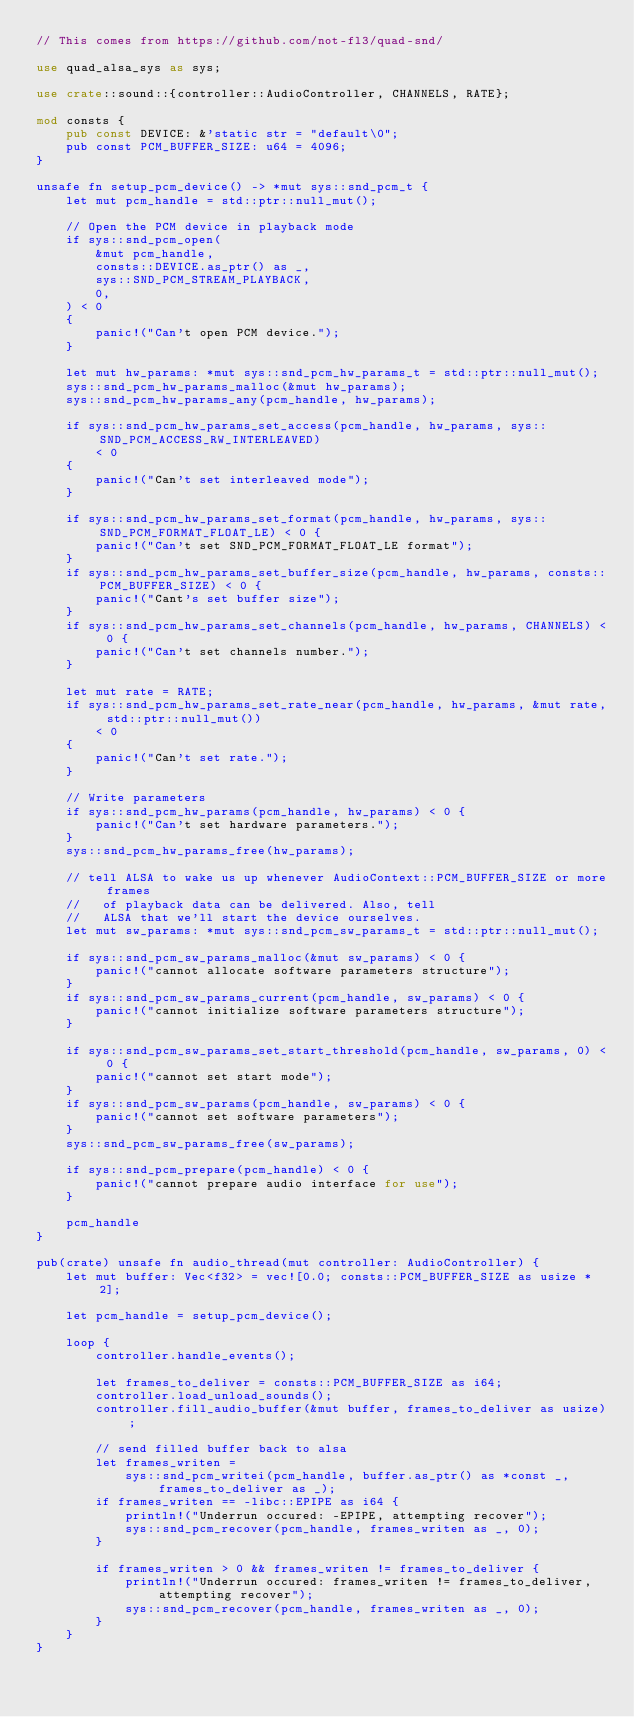<code> <loc_0><loc_0><loc_500><loc_500><_Rust_>// This comes from https://github.com/not-fl3/quad-snd/

use quad_alsa_sys as sys;

use crate::sound::{controller::AudioController, CHANNELS, RATE};

mod consts {
    pub const DEVICE: &'static str = "default\0";
    pub const PCM_BUFFER_SIZE: u64 = 4096;
}

unsafe fn setup_pcm_device() -> *mut sys::snd_pcm_t {
    let mut pcm_handle = std::ptr::null_mut();

    // Open the PCM device in playback mode
    if sys::snd_pcm_open(
        &mut pcm_handle,
        consts::DEVICE.as_ptr() as _,
        sys::SND_PCM_STREAM_PLAYBACK,
        0,
    ) < 0
    {
        panic!("Can't open PCM device.");
    }

    let mut hw_params: *mut sys::snd_pcm_hw_params_t = std::ptr::null_mut();
    sys::snd_pcm_hw_params_malloc(&mut hw_params);
    sys::snd_pcm_hw_params_any(pcm_handle, hw_params);

    if sys::snd_pcm_hw_params_set_access(pcm_handle, hw_params, sys::SND_PCM_ACCESS_RW_INTERLEAVED)
        < 0
    {
        panic!("Can't set interleaved mode");
    }

    if sys::snd_pcm_hw_params_set_format(pcm_handle, hw_params, sys::SND_PCM_FORMAT_FLOAT_LE) < 0 {
        panic!("Can't set SND_PCM_FORMAT_FLOAT_LE format");
    }
    if sys::snd_pcm_hw_params_set_buffer_size(pcm_handle, hw_params, consts::PCM_BUFFER_SIZE) < 0 {
        panic!("Cant's set buffer size");
    }
    if sys::snd_pcm_hw_params_set_channels(pcm_handle, hw_params, CHANNELS) < 0 {
        panic!("Can't set channels number.");
    }

    let mut rate = RATE;
    if sys::snd_pcm_hw_params_set_rate_near(pcm_handle, hw_params, &mut rate, std::ptr::null_mut())
        < 0
    {
        panic!("Can't set rate.");
    }

    // Write parameters
    if sys::snd_pcm_hw_params(pcm_handle, hw_params) < 0 {
        panic!("Can't set hardware parameters.");
    }
    sys::snd_pcm_hw_params_free(hw_params);

    // tell ALSA to wake us up whenever AudioContext::PCM_BUFFER_SIZE or more frames
    //   of playback data can be delivered. Also, tell
    //   ALSA that we'll start the device ourselves.
    let mut sw_params: *mut sys::snd_pcm_sw_params_t = std::ptr::null_mut();

    if sys::snd_pcm_sw_params_malloc(&mut sw_params) < 0 {
        panic!("cannot allocate software parameters structure");
    }
    if sys::snd_pcm_sw_params_current(pcm_handle, sw_params) < 0 {
        panic!("cannot initialize software parameters structure");
    }

    if sys::snd_pcm_sw_params_set_start_threshold(pcm_handle, sw_params, 0) < 0 {
        panic!("cannot set start mode");
    }
    if sys::snd_pcm_sw_params(pcm_handle, sw_params) < 0 {
        panic!("cannot set software parameters");
    }
    sys::snd_pcm_sw_params_free(sw_params);

    if sys::snd_pcm_prepare(pcm_handle) < 0 {
        panic!("cannot prepare audio interface for use");
    }

    pcm_handle
}

pub(crate) unsafe fn audio_thread(mut controller: AudioController) {
    let mut buffer: Vec<f32> = vec![0.0; consts::PCM_BUFFER_SIZE as usize * 2];

    let pcm_handle = setup_pcm_device();

    loop {
        controller.handle_events();

        let frames_to_deliver = consts::PCM_BUFFER_SIZE as i64;
        controller.load_unload_sounds();
        controller.fill_audio_buffer(&mut buffer, frames_to_deliver as usize);

        // send filled buffer back to alsa
        let frames_writen =
            sys::snd_pcm_writei(pcm_handle, buffer.as_ptr() as *const _, frames_to_deliver as _);
        if frames_writen == -libc::EPIPE as i64 {
            println!("Underrun occured: -EPIPE, attempting recover");
            sys::snd_pcm_recover(pcm_handle, frames_writen as _, 0);
        }

        if frames_writen > 0 && frames_writen != frames_to_deliver {
            println!("Underrun occured: frames_writen != frames_to_deliver, attempting recover");
            sys::snd_pcm_recover(pcm_handle, frames_writen as _, 0);
        }
    }
}
</code> 